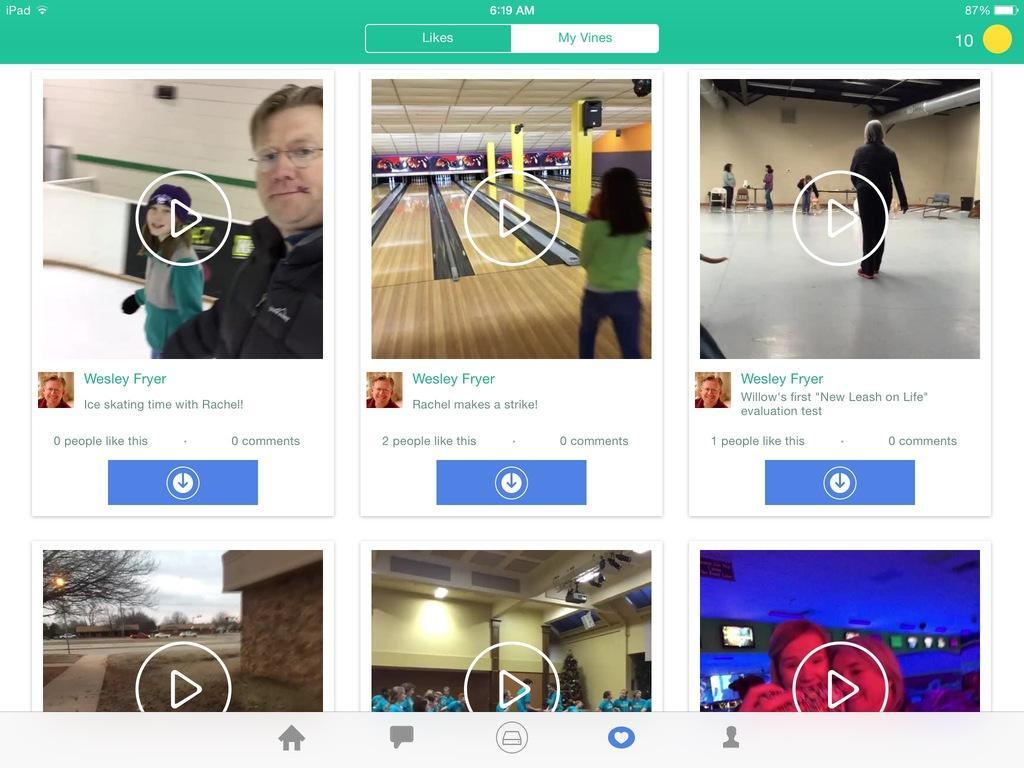How would you summarize this image in a sentence or two? In this image we can see that there are screenshot images of videos. In this image there are six small images which are collided one beside the other. On the left side there is a man. At the bottom there is a ground. 